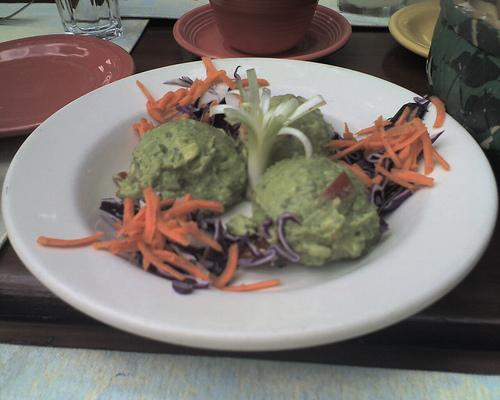What type of meal does this appear to be? Please explain your reasoning. vegetarian. The meal is made out of guacamole, carrots, and cabbage. 